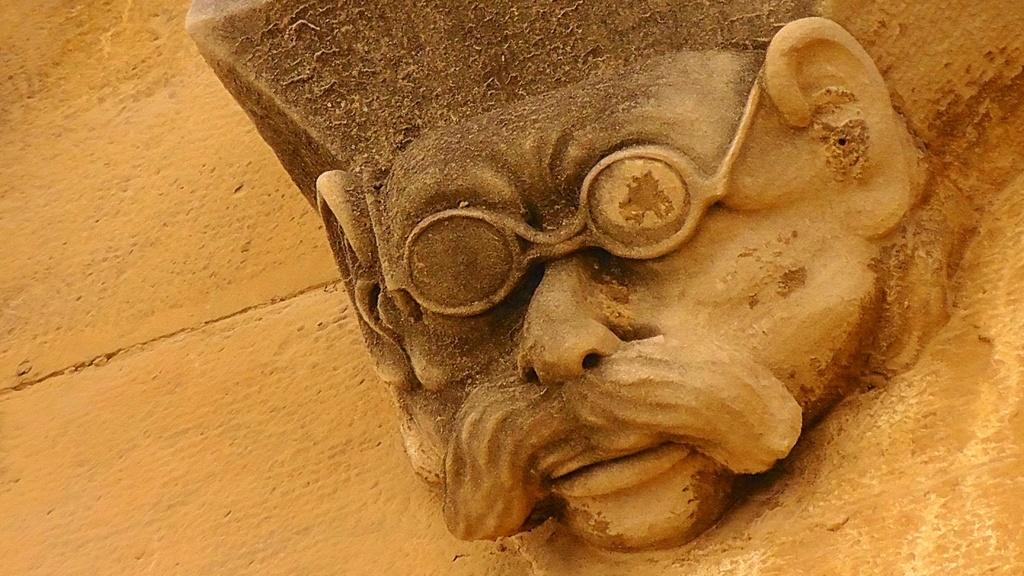What is the main subject of the image? The image contains an art piece. What does the art piece depict? The art piece depicts a human being. What accessory is the human being in the art piece wearing? The human being in the art piece is wearing spectacles. Is the human being in the art piece receiving any blood transfusion or treatment in the image? There is no indication in the image that the human being in the art piece is receiving any blood transfusion or treatment. What type of education is the human being in the art piece pursuing in the image? There is no indication in the image about the human being's education. 